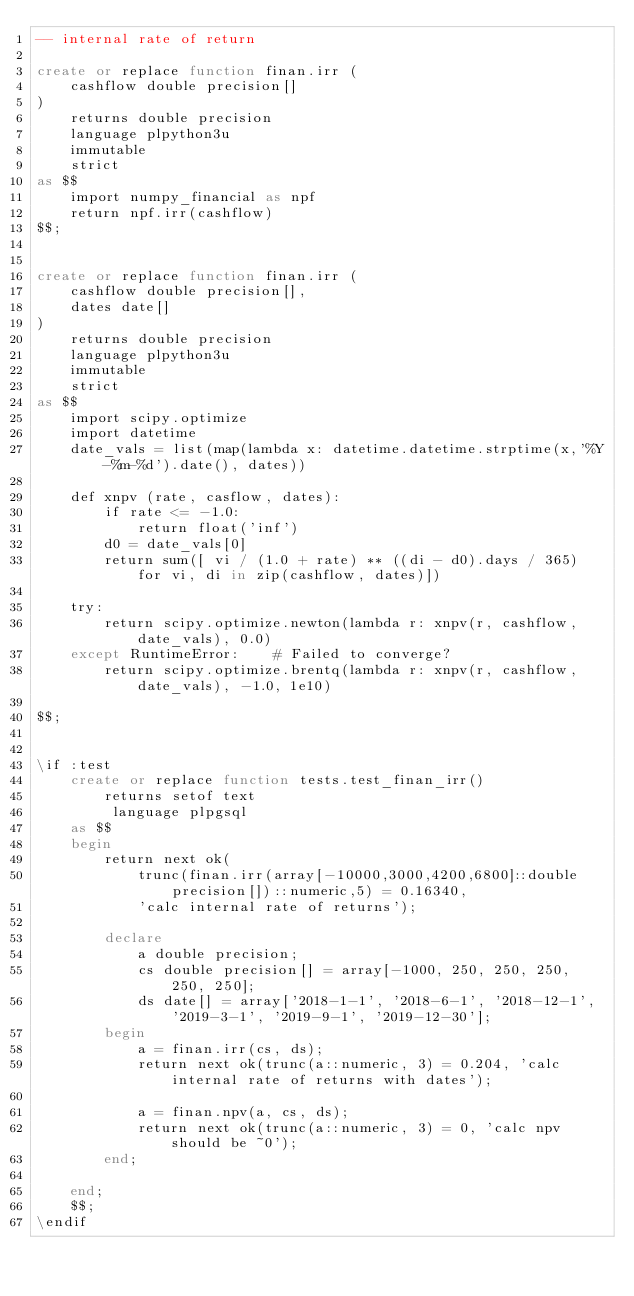Convert code to text. <code><loc_0><loc_0><loc_500><loc_500><_SQL_>-- internal rate of return

create or replace function finan.irr (
    cashflow double precision[]
)
    returns double precision
    language plpython3u
    immutable
    strict
as $$
    import numpy_financial as npf
    return npf.irr(cashflow)
$$;


create or replace function finan.irr (
    cashflow double precision[],
    dates date[]
)
    returns double precision
    language plpython3u
    immutable
    strict
as $$
    import scipy.optimize
    import datetime
    date_vals = list(map(lambda x: datetime.datetime.strptime(x,'%Y-%m-%d').date(), dates))

    def xnpv (rate, casflow, dates):
        if rate <= -1.0:
            return float('inf')
        d0 = date_vals[0]
        return sum([ vi / (1.0 + rate) ** ((di - d0).days / 365) for vi, di in zip(cashflow, dates)])

    try:
        return scipy.optimize.newton(lambda r: xnpv(r, cashflow, date_vals), 0.0)
    except RuntimeError:    # Failed to converge?
        return scipy.optimize.brentq(lambda r: xnpv(r, cashflow, date_vals), -1.0, 1e10)

$$;


\if :test
    create or replace function tests.test_finan_irr()
        returns setof text
         language plpgsql
    as $$
    begin
        return next ok(
            trunc(finan.irr(array[-10000,3000,4200,6800]::double precision[])::numeric,5) = 0.16340,
            'calc internal rate of returns');

        declare
            a double precision;
            cs double precision[] = array[-1000, 250, 250, 250, 250, 250];
            ds date[] = array['2018-1-1', '2018-6-1', '2018-12-1', '2019-3-1', '2019-9-1', '2019-12-30'];
        begin
            a = finan.irr(cs, ds);
            return next ok(trunc(a::numeric, 3) = 0.204, 'calc internal rate of returns with dates');

            a = finan.npv(a, cs, ds);
            return next ok(trunc(a::numeric, 3) = 0, 'calc npv should be ~0');
        end;

    end;
    $$;
\endif
</code> 